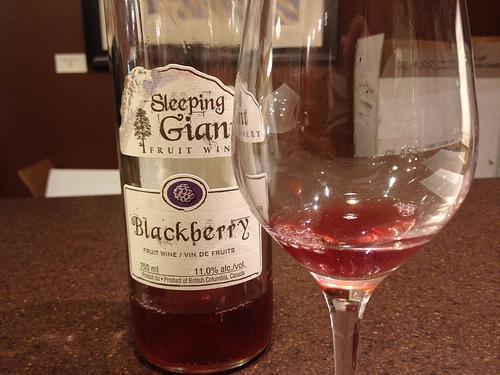How many bottles of wine are there?
Give a very brief answer. 1. How many glasses are there?
Give a very brief answer. 1. 